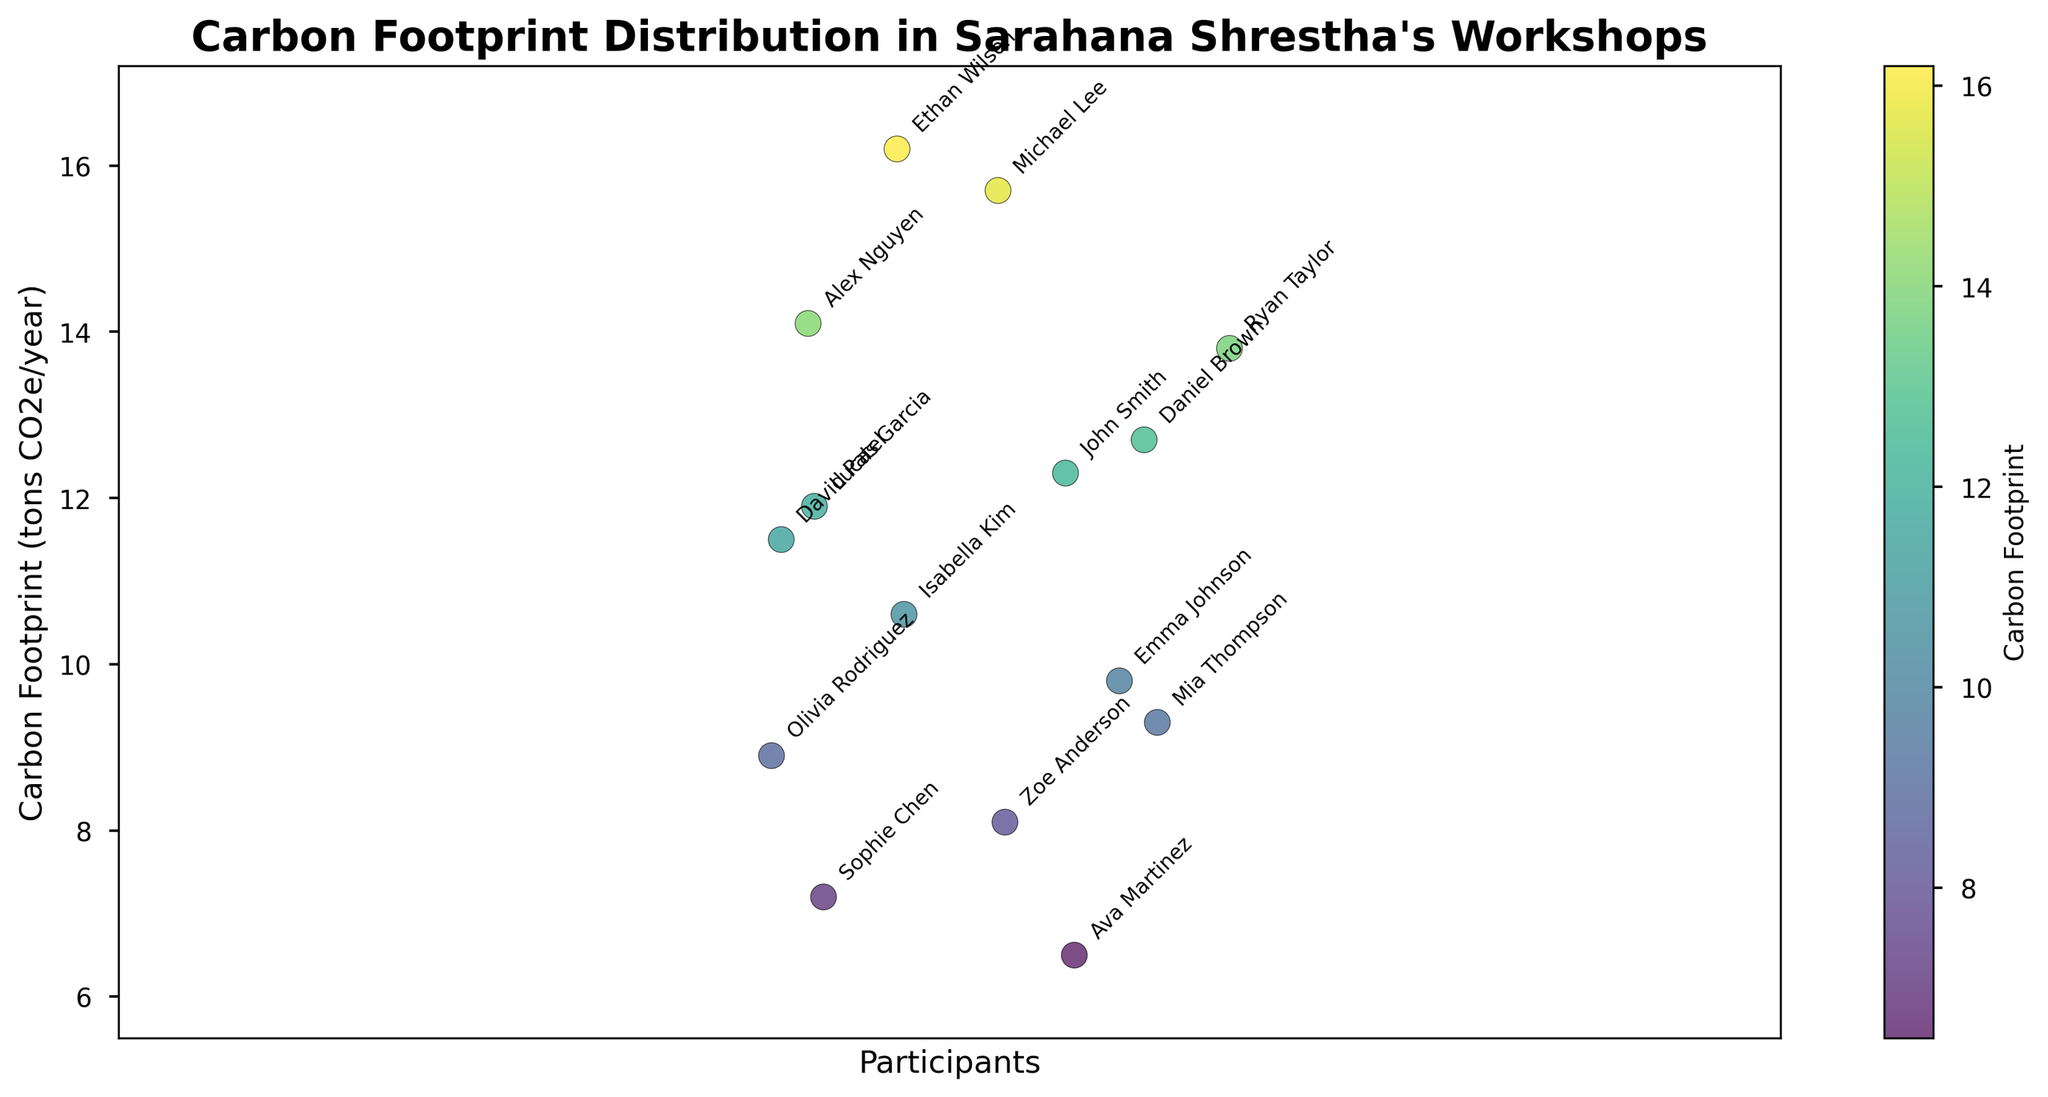What is the title of the plot? The title is prominently displayed at the top of the plot and is written in bold text.
Answer: Carbon Footprint Distribution in Sarahana Shrestha's Workshops How many participants are plotted? Each participant is represented by a labeled point on the scatter plot. You can count the number of unique labels.
Answer: 15 What is the carbon footprint of the participant with the lowest value? The lowest point on the y-axis represents the participant with the smallest carbon footprint. Identify the corresponding label and value.
Answer: 6.5 tons CO2e/year (Ava Martinez) Which participant has the highest carbon footprint? The highest point on the y-axis corresponds to the participant with the maximum carbon footprint.
Answer: Ethan Wilson What is the range of carbon footprints among the participants? To find the range, subtract the smallest carbon footprint from the largest. The lowest value is 6.5, and the highest value is 16.2.
Answer: 9.7 tons CO2e/year What is the color scheme used in the plot, and what does it represent? The colors on the plot are part of a gradient color scheme (viridis) that corresponds to the carbon footprint values. Darker colors typically represent higher values, and lighter colors represent lower values. This can be confirmed by the color bar.
Answer: Gradient (viridis) representing carbon footprints What is the average carbon footprint of the participants? Sum all the carbon footprint values and divide by the number of participants. The sum is 157.5 (12.3 + 9.8 + 15.7 + 7.2 + 11.5 + 8.9 + 14.1 + 10.6 + 13.8 + 6.5 + 16.2 + 9.3 + 12.7 + 8.1 + 11.9), and the number of participants is 15, so the average is 157.5 / 15.
Answer: 10.5 tons CO2e/year How many participants have a carbon footprint above 10 tons CO2e/year? Count the number of points above the y-axis value of 10 in the plot.
Answer: 8 Compare the carbon footprints of Emma Johnson and Lucas Garcia. Who has a higher value? Locate the points labeled "Emma Johnson" and "Lucas Garcia" on the plot and compare their y-axis values. Emma Johnson has 9.8 and Lucas Garcia has 11.9.
Answer: Lucas Garcia Which participant has a carbon footprint closest to the average carbon footprint value of the group? Calculate the average (10.5) and find the participant whose footprint is nearest this value by comparing the differences. Isabella Kim has 10.6, which is closest to 10.5.
Answer: Isabella Kim 